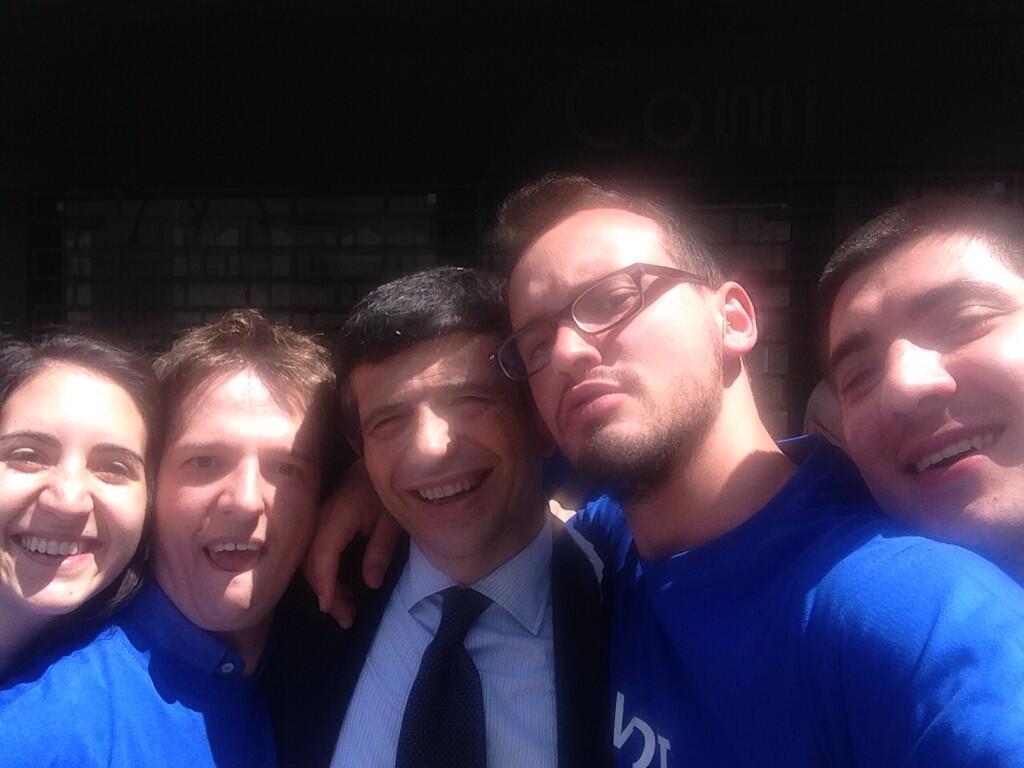Please provide a concise description of this image. In this image I see 4 men and a woman and I see that these 4 of them are smiling and I see that these both are wearing blue t-shirt and this man is wearing a suit and I see that it is a bit dark in the background. 